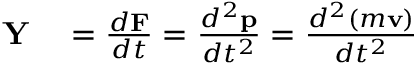<formula> <loc_0><loc_0><loc_500><loc_500>\begin{array} { r l } { Y } & = { \frac { d F } { d t } } = { \frac { d ^ { 2 } p } { d t ^ { 2 } } } = { \frac { d ^ { 2 } ( m v ) } { d t ^ { 2 } } } } \end{array}</formula> 